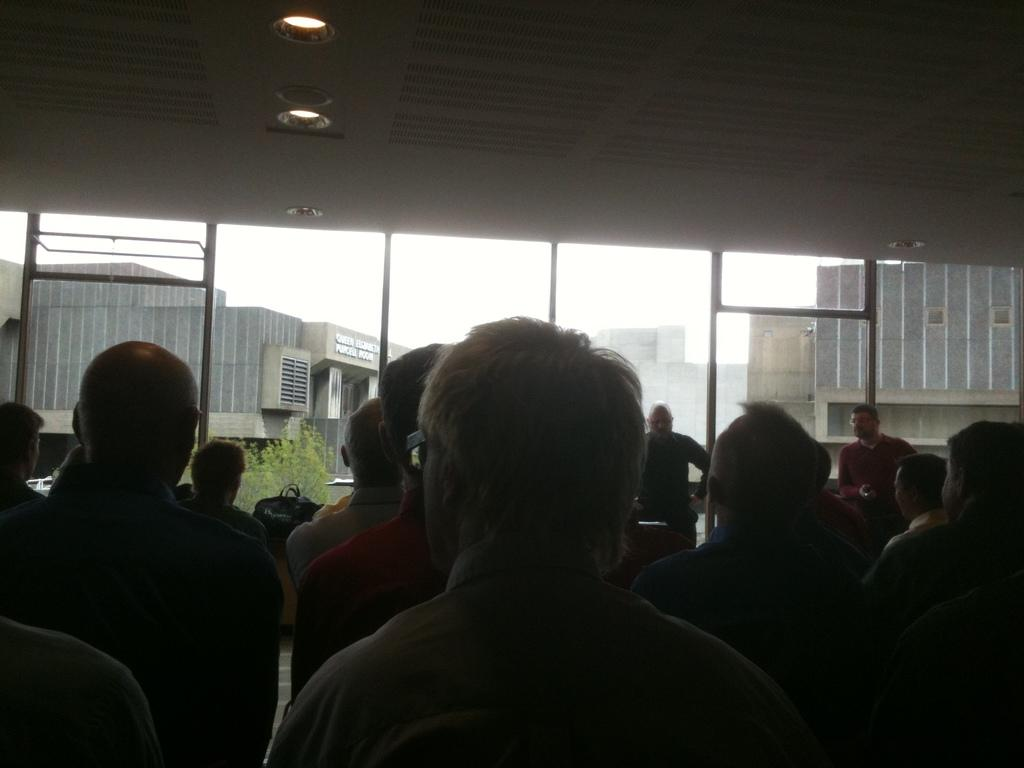How many individuals are present in the image? There are many people in the image. What can be seen behind the people? There are glass windows behind the people. What is visible through the windows? Trees and buildings can be seen through the windows. Where are the lights located in the image? The lights are at the top of the image. What is the reaction of the people to the quarter that is not present in the image? There is no quarter present in the image, and therefore no reaction can be observed. 